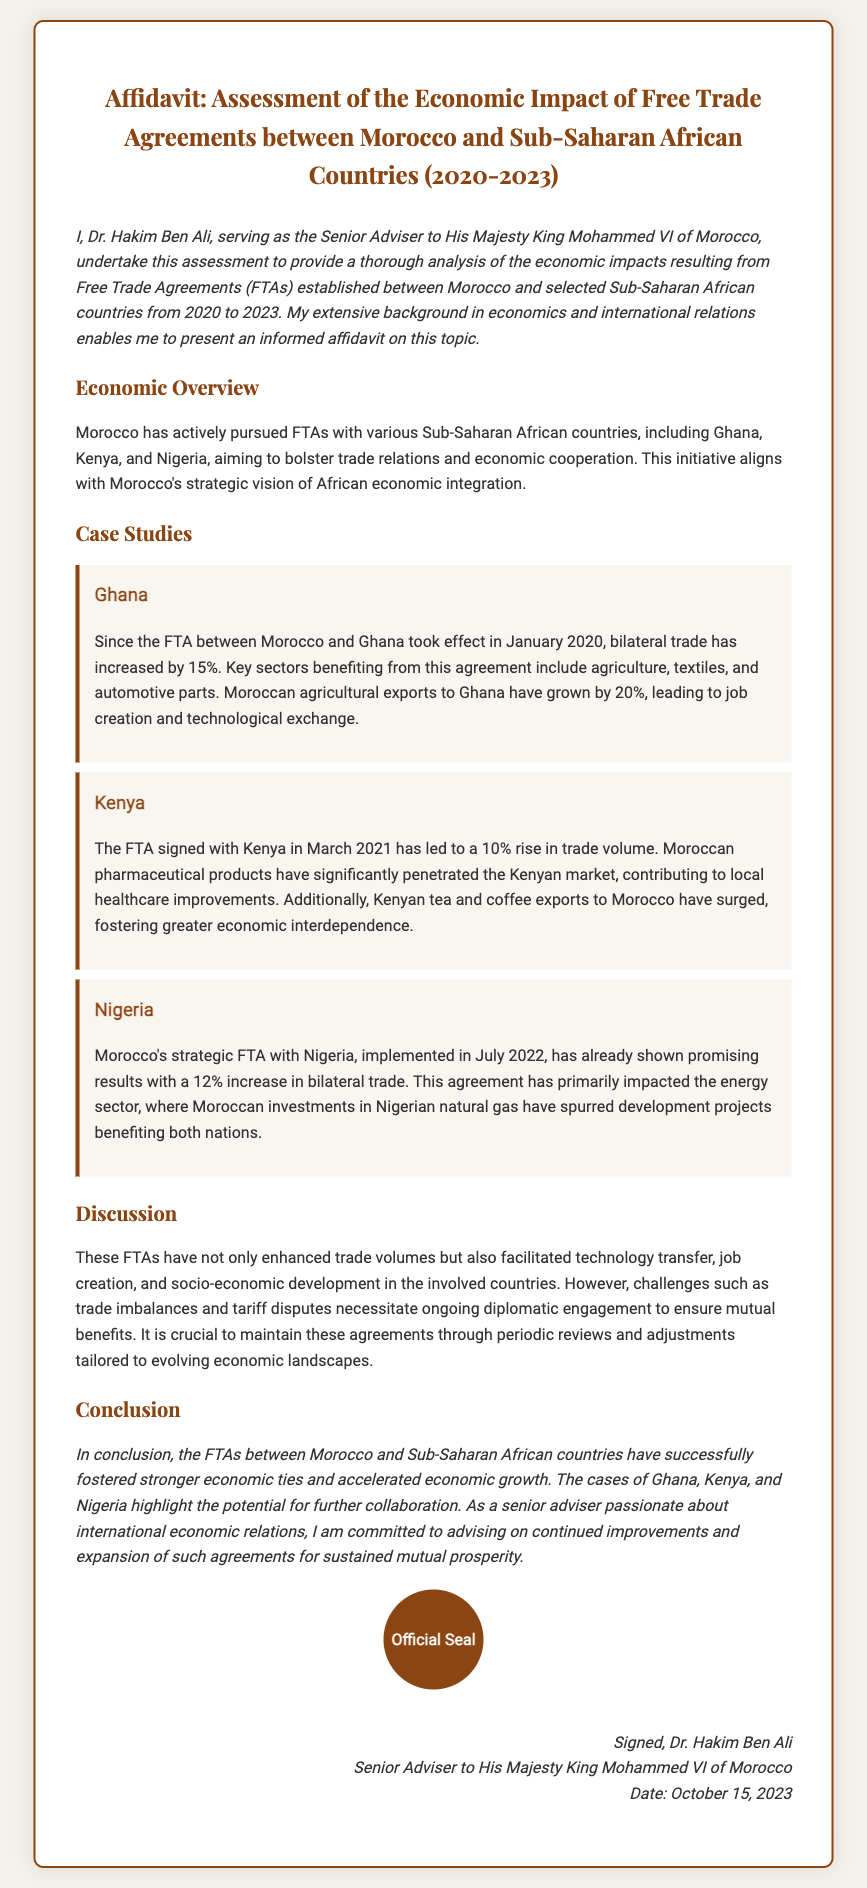what is the title of the affidavit? The title of the affidavit outlines the document's purpose and focus, which is the economic impact of FTAs between Morocco and Sub-Saharan African countries.
Answer: Affidavit: Assessment of the Economic Impact of Free Trade Agreements between Morocco and Sub-Saharan African Countries (2020-2023) who is the author of the affidavit? The author of the affidavit is introduced in the introduction section, stating his position and role.
Answer: Dr. Hakim Ben Ali what is the date of the affidavit? The date is provided in the signature section at the end of the document, indicating when the affidavit was signed.
Answer: October 15, 2023 which Sub-Saharan African country had a 15% increase in trade? The specific country that achieved this increase is mentioned in the Ghana case study.
Answer: Ghana when did the FTA with Kenya take effect? The effective date of the FTA with Kenya is mentioned in its corresponding case study in the document.
Answer: March 2021 what sector heavily benefited from the FTA with Nigeria? The primary sector that is noted for significant impact from the FTA is provided in the Nigerian case study.
Answer: Energy what is the main benefit of the FTA with Ghana? The main outcome mentioned for the FTA with Ghana is provided as a significant achievement in the case study.
Answer: Job creation and technological exchange how many Sub-Saharan African countries are specifically mentioned in the affidavit? The number of countries discussed regarding FTAs is indicated in the first section of the document where they're listed.
Answer: Three 